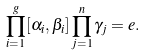Convert formula to latex. <formula><loc_0><loc_0><loc_500><loc_500>\prod _ { i = 1 } ^ { g } [ \alpha _ { i } , \beta _ { i } ] \prod _ { j = 1 } ^ { n } \gamma _ { j } = e .</formula> 